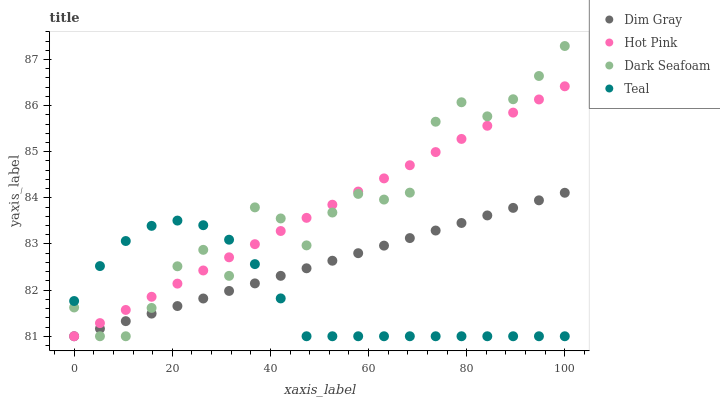Does Teal have the minimum area under the curve?
Answer yes or no. Yes. Does Dark Seafoam have the maximum area under the curve?
Answer yes or no. Yes. Does Dim Gray have the minimum area under the curve?
Answer yes or no. No. Does Dim Gray have the maximum area under the curve?
Answer yes or no. No. Is Hot Pink the smoothest?
Answer yes or no. Yes. Is Dark Seafoam the roughest?
Answer yes or no. Yes. Is Dim Gray the smoothest?
Answer yes or no. No. Is Dim Gray the roughest?
Answer yes or no. No. Does Dark Seafoam have the lowest value?
Answer yes or no. Yes. Does Dark Seafoam have the highest value?
Answer yes or no. Yes. Does Dim Gray have the highest value?
Answer yes or no. No. Does Dark Seafoam intersect Teal?
Answer yes or no. Yes. Is Dark Seafoam less than Teal?
Answer yes or no. No. Is Dark Seafoam greater than Teal?
Answer yes or no. No. 